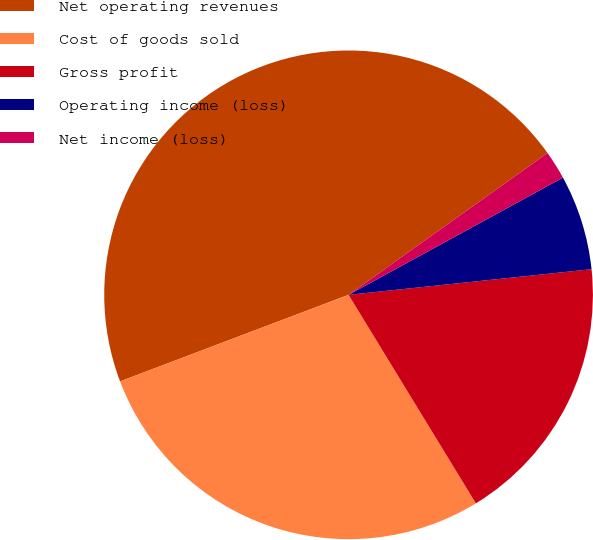<chart> <loc_0><loc_0><loc_500><loc_500><pie_chart><fcel>Net operating revenues<fcel>Cost of goods sold<fcel>Gross profit<fcel>Operating income (loss)<fcel>Net income (loss)<nl><fcel>45.91%<fcel>27.96%<fcel>17.95%<fcel>6.29%<fcel>1.89%<nl></chart> 